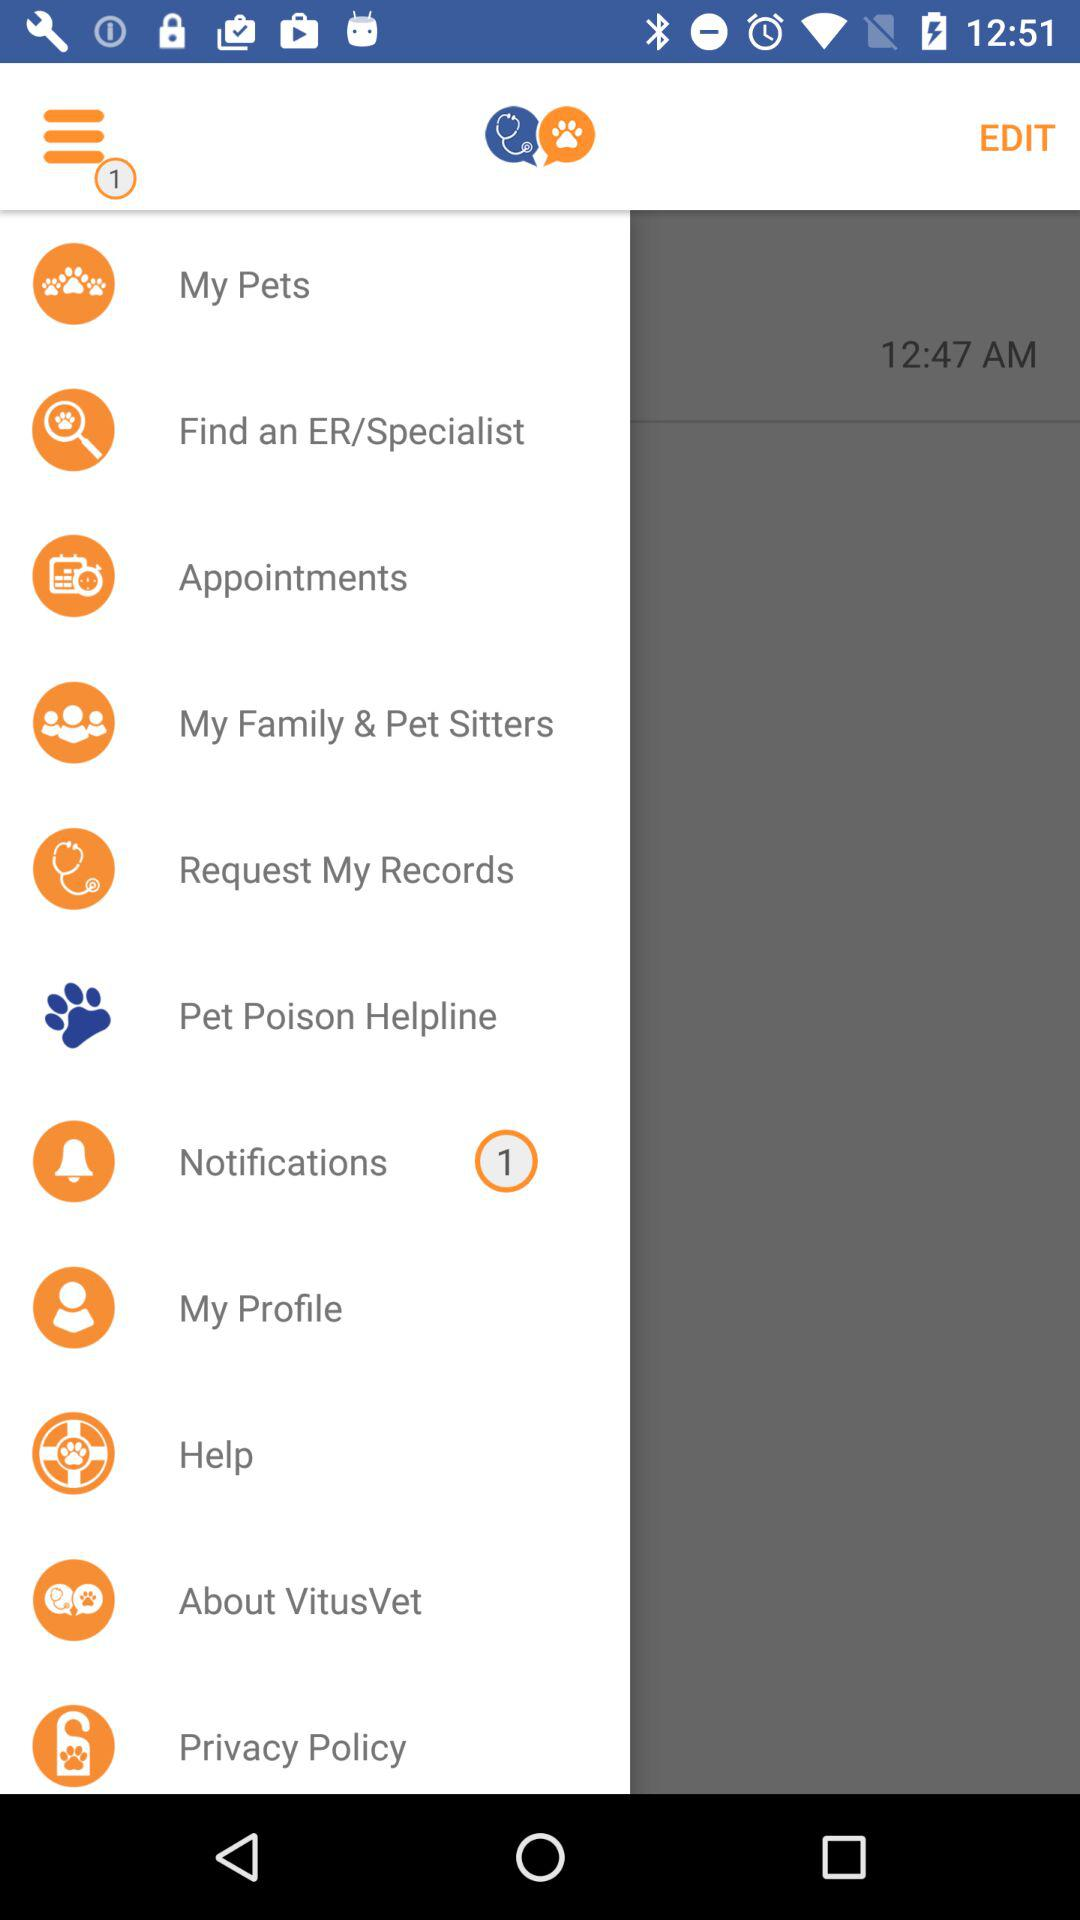Are there any unread notifications? There is 1 unread notification. 